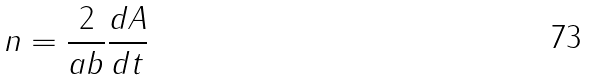<formula> <loc_0><loc_0><loc_500><loc_500>n = \frac { 2 } { a b } \frac { d A } { d t }</formula> 